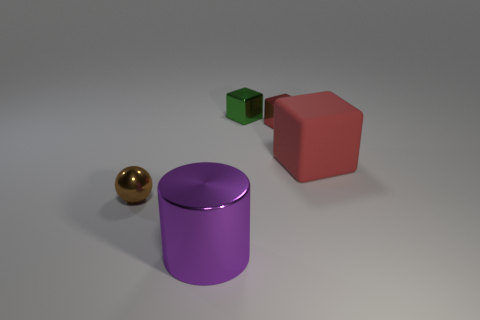Add 1 green shiny things. How many objects exist? 6 Subtract all blocks. How many objects are left? 2 Subtract 0 yellow blocks. How many objects are left? 5 Subtract all red things. Subtract all cyan metal cylinders. How many objects are left? 3 Add 4 brown metallic spheres. How many brown metallic spheres are left? 5 Add 5 big metal spheres. How many big metal spheres exist? 5 